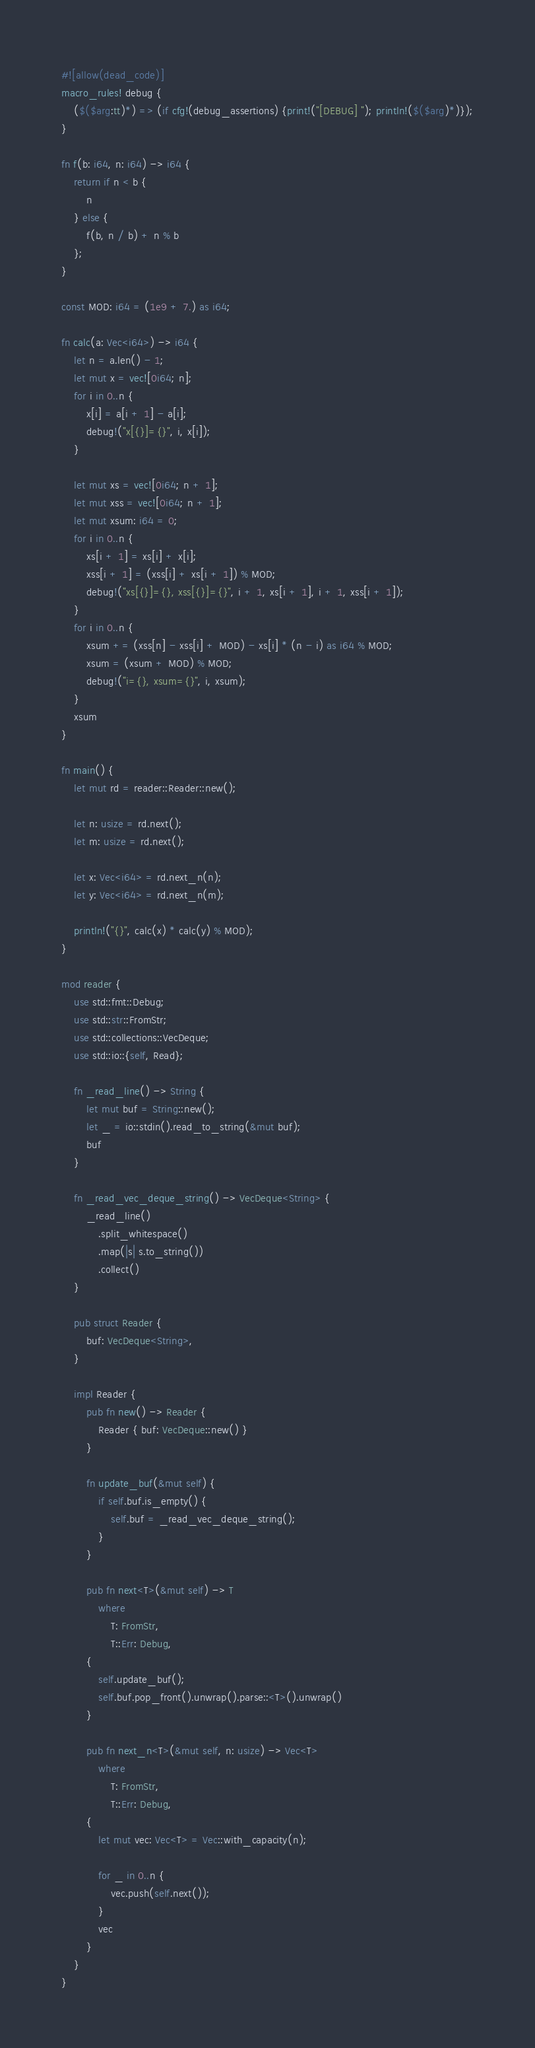Convert code to text. <code><loc_0><loc_0><loc_500><loc_500><_Rust_>#![allow(dead_code)]
macro_rules! debug {
    ($($arg:tt)*) => (if cfg!(debug_assertions) {print!("[DEBUG] "); println!($($arg)*)});
}

fn f(b: i64, n: i64) -> i64 {
    return if n < b {
        n
    } else {
        f(b, n / b) + n % b
    };
}

const MOD: i64 = (1e9 + 7.) as i64;

fn calc(a: Vec<i64>) -> i64 {
    let n = a.len() - 1;
    let mut x = vec![0i64; n];
    for i in 0..n {
        x[i] = a[i + 1] - a[i];
        debug!("x[{}]={}", i, x[i]);
    }

    let mut xs = vec![0i64; n + 1];
    let mut xss = vec![0i64; n + 1];
    let mut xsum: i64 = 0;
    for i in 0..n {
        xs[i + 1] = xs[i] + x[i];
        xss[i + 1] = (xss[i] + xs[i + 1]) % MOD;
        debug!("xs[{}]={}, xss[{}]={}", i + 1, xs[i + 1], i + 1, xss[i + 1]);
    }
    for i in 0..n {
        xsum += (xss[n] - xss[i] + MOD) - xs[i] * (n - i) as i64 % MOD;
        xsum = (xsum + MOD) % MOD;
        debug!("i={}, xsum={}", i, xsum);
    }
    xsum
}

fn main() {
    let mut rd = reader::Reader::new();

    let n: usize = rd.next();
    let m: usize = rd.next();

    let x: Vec<i64> = rd.next_n(n);
    let y: Vec<i64> = rd.next_n(m);

    println!("{}", calc(x) * calc(y) % MOD);
}

mod reader {
    use std::fmt::Debug;
    use std::str::FromStr;
    use std::collections::VecDeque;
    use std::io::{self, Read};

    fn _read_line() -> String {
        let mut buf = String::new();
        let _ = io::stdin().read_to_string(&mut buf);
        buf
    }

    fn _read_vec_deque_string() -> VecDeque<String> {
        _read_line()
            .split_whitespace()
            .map(|s| s.to_string())
            .collect()
    }

    pub struct Reader {
        buf: VecDeque<String>,
    }

    impl Reader {
        pub fn new() -> Reader {
            Reader { buf: VecDeque::new() }
        }

        fn update_buf(&mut self) {
            if self.buf.is_empty() {
                self.buf = _read_vec_deque_string();
            }
        }

        pub fn next<T>(&mut self) -> T
            where
                T: FromStr,
                T::Err: Debug,
        {
            self.update_buf();
            self.buf.pop_front().unwrap().parse::<T>().unwrap()
        }

        pub fn next_n<T>(&mut self, n: usize) -> Vec<T>
            where
                T: FromStr,
                T::Err: Debug,
        {
            let mut vec: Vec<T> = Vec::with_capacity(n);

            for _ in 0..n {
                vec.push(self.next());
            }
            vec
        }
    }
}
</code> 